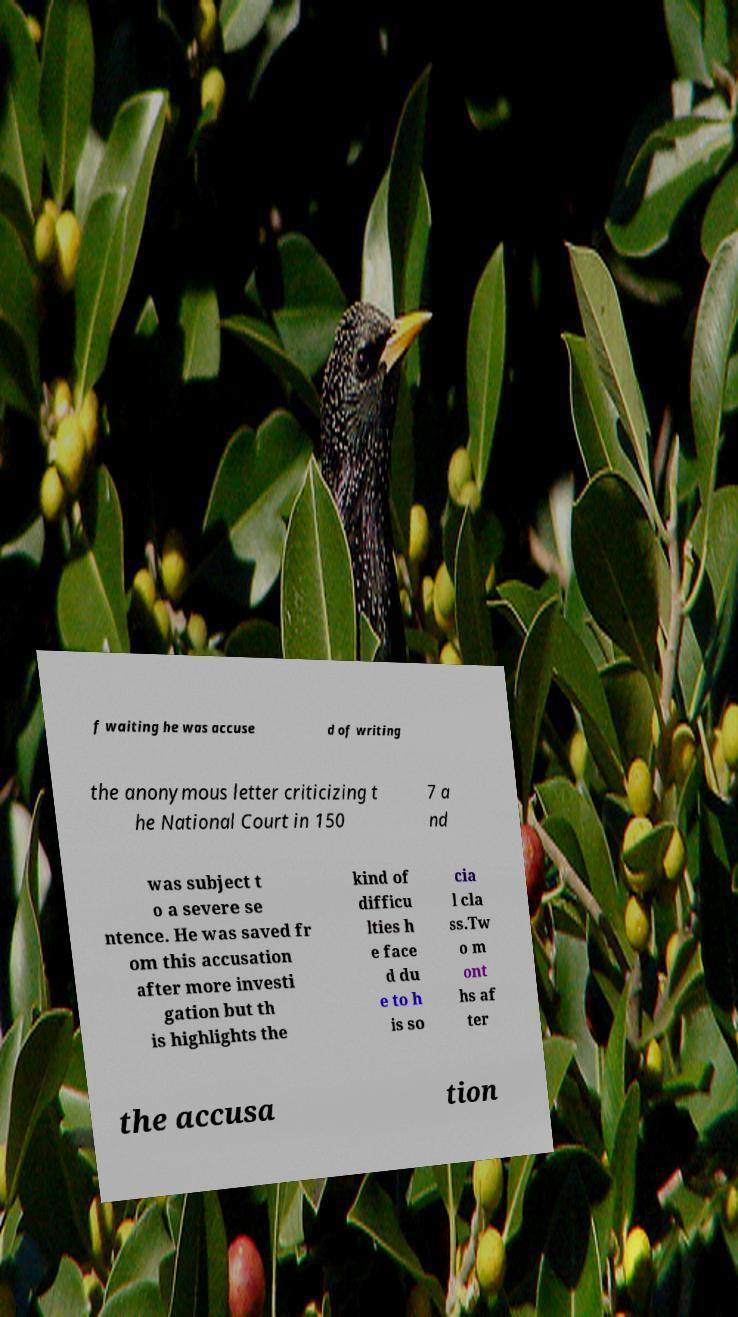Can you accurately transcribe the text from the provided image for me? f waiting he was accuse d of writing the anonymous letter criticizing t he National Court in 150 7 a nd was subject t o a severe se ntence. He was saved fr om this accusation after more investi gation but th is highlights the kind of difficu lties h e face d du e to h is so cia l cla ss.Tw o m ont hs af ter the accusa tion 